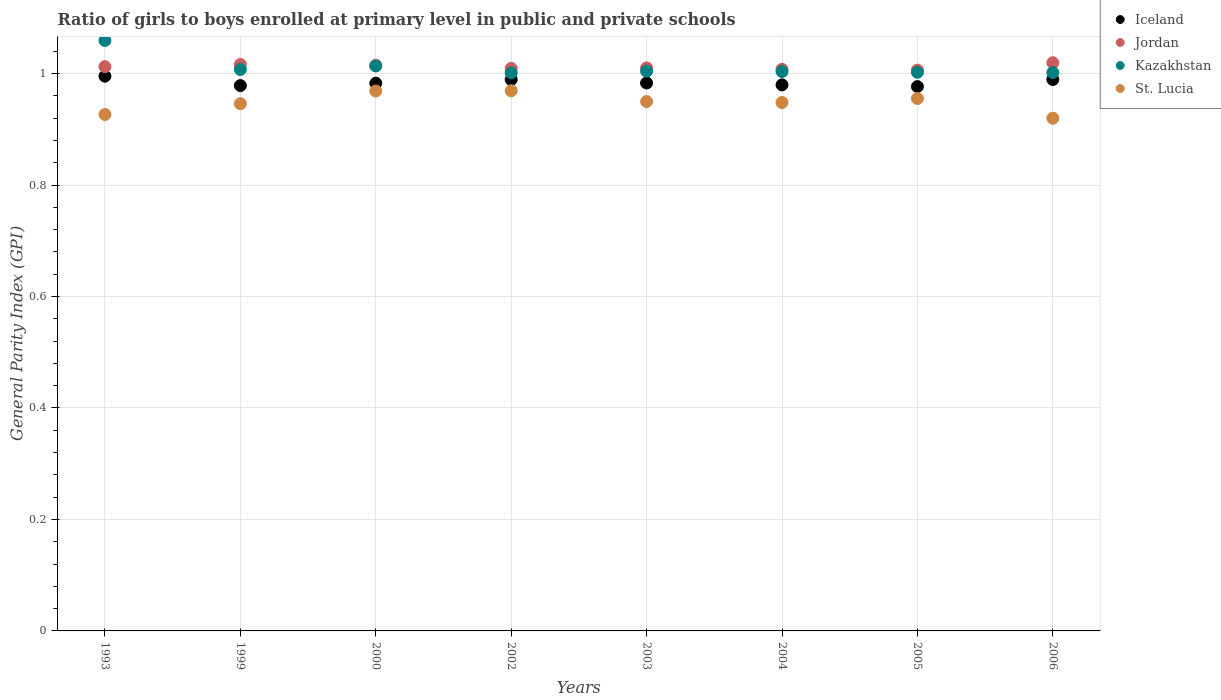Is the number of dotlines equal to the number of legend labels?
Provide a short and direct response. Yes. What is the general parity index in Kazakhstan in 2003?
Your response must be concise. 1. Across all years, what is the maximum general parity index in Iceland?
Your answer should be compact. 1. Across all years, what is the minimum general parity index in Iceland?
Provide a short and direct response. 0.98. What is the total general parity index in Jordan in the graph?
Offer a terse response. 8.1. What is the difference between the general parity index in Iceland in 2000 and that in 2003?
Your response must be concise. -0. What is the difference between the general parity index in St. Lucia in 1993 and the general parity index in Kazakhstan in 2000?
Your answer should be very brief. -0.09. What is the average general parity index in Jordan per year?
Make the answer very short. 1.01. In the year 2005, what is the difference between the general parity index in Kazakhstan and general parity index in St. Lucia?
Your answer should be very brief. 0.05. What is the ratio of the general parity index in Jordan in 1999 to that in 2005?
Provide a succinct answer. 1.01. What is the difference between the highest and the second highest general parity index in Jordan?
Your answer should be compact. 0. What is the difference between the highest and the lowest general parity index in Kazakhstan?
Provide a succinct answer. 0.06. In how many years, is the general parity index in Iceland greater than the average general parity index in Iceland taken over all years?
Offer a very short reply. 3. Is the sum of the general parity index in Iceland in 2002 and 2004 greater than the maximum general parity index in Jordan across all years?
Offer a very short reply. Yes. Is it the case that in every year, the sum of the general parity index in St. Lucia and general parity index in Jordan  is greater than the sum of general parity index in Iceland and general parity index in Kazakhstan?
Your response must be concise. Yes. Is it the case that in every year, the sum of the general parity index in St. Lucia and general parity index in Kazakhstan  is greater than the general parity index in Iceland?
Your answer should be compact. Yes. How many dotlines are there?
Make the answer very short. 4. How many years are there in the graph?
Keep it short and to the point. 8. What is the difference between two consecutive major ticks on the Y-axis?
Your answer should be very brief. 0.2. Are the values on the major ticks of Y-axis written in scientific E-notation?
Provide a succinct answer. No. Does the graph contain any zero values?
Offer a very short reply. No. Does the graph contain grids?
Offer a very short reply. Yes. Where does the legend appear in the graph?
Provide a succinct answer. Top right. How are the legend labels stacked?
Your response must be concise. Vertical. What is the title of the graph?
Your answer should be very brief. Ratio of girls to boys enrolled at primary level in public and private schools. Does "Turks and Caicos Islands" appear as one of the legend labels in the graph?
Offer a very short reply. No. What is the label or title of the Y-axis?
Keep it short and to the point. General Parity Index (GPI). What is the General Parity Index (GPI) of Jordan in 1993?
Provide a short and direct response. 1.01. What is the General Parity Index (GPI) of Kazakhstan in 1993?
Ensure brevity in your answer.  1.06. What is the General Parity Index (GPI) of St. Lucia in 1993?
Give a very brief answer. 0.93. What is the General Parity Index (GPI) in Iceland in 1999?
Give a very brief answer. 0.98. What is the General Parity Index (GPI) of Jordan in 1999?
Provide a short and direct response. 1.02. What is the General Parity Index (GPI) of Kazakhstan in 1999?
Keep it short and to the point. 1.01. What is the General Parity Index (GPI) in St. Lucia in 1999?
Offer a very short reply. 0.95. What is the General Parity Index (GPI) of Iceland in 2000?
Make the answer very short. 0.98. What is the General Parity Index (GPI) in Jordan in 2000?
Your answer should be compact. 1.01. What is the General Parity Index (GPI) of Kazakhstan in 2000?
Give a very brief answer. 1.01. What is the General Parity Index (GPI) of St. Lucia in 2000?
Give a very brief answer. 0.97. What is the General Parity Index (GPI) in Iceland in 2002?
Offer a very short reply. 0.99. What is the General Parity Index (GPI) of Jordan in 2002?
Give a very brief answer. 1.01. What is the General Parity Index (GPI) of Kazakhstan in 2002?
Offer a terse response. 1. What is the General Parity Index (GPI) in St. Lucia in 2002?
Make the answer very short. 0.97. What is the General Parity Index (GPI) of Iceland in 2003?
Your answer should be very brief. 0.98. What is the General Parity Index (GPI) in Jordan in 2003?
Your response must be concise. 1.01. What is the General Parity Index (GPI) in Kazakhstan in 2003?
Your answer should be compact. 1. What is the General Parity Index (GPI) of St. Lucia in 2003?
Provide a succinct answer. 0.95. What is the General Parity Index (GPI) in Iceland in 2004?
Your answer should be compact. 0.98. What is the General Parity Index (GPI) in Jordan in 2004?
Give a very brief answer. 1.01. What is the General Parity Index (GPI) of Kazakhstan in 2004?
Provide a short and direct response. 1. What is the General Parity Index (GPI) of St. Lucia in 2004?
Your response must be concise. 0.95. What is the General Parity Index (GPI) in Iceland in 2005?
Provide a short and direct response. 0.98. What is the General Parity Index (GPI) of Jordan in 2005?
Make the answer very short. 1.01. What is the General Parity Index (GPI) of Kazakhstan in 2005?
Make the answer very short. 1. What is the General Parity Index (GPI) in St. Lucia in 2005?
Provide a succinct answer. 0.96. What is the General Parity Index (GPI) of Iceland in 2006?
Your answer should be compact. 0.99. What is the General Parity Index (GPI) in Jordan in 2006?
Offer a very short reply. 1.02. What is the General Parity Index (GPI) of Kazakhstan in 2006?
Offer a terse response. 1. What is the General Parity Index (GPI) in St. Lucia in 2006?
Your response must be concise. 0.92. Across all years, what is the maximum General Parity Index (GPI) of Jordan?
Offer a very short reply. 1.02. Across all years, what is the maximum General Parity Index (GPI) of Kazakhstan?
Offer a very short reply. 1.06. Across all years, what is the maximum General Parity Index (GPI) of St. Lucia?
Ensure brevity in your answer.  0.97. Across all years, what is the minimum General Parity Index (GPI) in Iceland?
Provide a succinct answer. 0.98. Across all years, what is the minimum General Parity Index (GPI) in Jordan?
Keep it short and to the point. 1.01. Across all years, what is the minimum General Parity Index (GPI) in Kazakhstan?
Your answer should be compact. 1. Across all years, what is the minimum General Parity Index (GPI) in St. Lucia?
Provide a succinct answer. 0.92. What is the total General Parity Index (GPI) of Iceland in the graph?
Provide a short and direct response. 7.87. What is the total General Parity Index (GPI) of Jordan in the graph?
Make the answer very short. 8.1. What is the total General Parity Index (GPI) in Kazakhstan in the graph?
Give a very brief answer. 8.09. What is the total General Parity Index (GPI) in St. Lucia in the graph?
Ensure brevity in your answer.  7.58. What is the difference between the General Parity Index (GPI) of Iceland in 1993 and that in 1999?
Make the answer very short. 0.02. What is the difference between the General Parity Index (GPI) in Jordan in 1993 and that in 1999?
Keep it short and to the point. -0. What is the difference between the General Parity Index (GPI) of Kazakhstan in 1993 and that in 1999?
Give a very brief answer. 0.05. What is the difference between the General Parity Index (GPI) in St. Lucia in 1993 and that in 1999?
Make the answer very short. -0.02. What is the difference between the General Parity Index (GPI) in Iceland in 1993 and that in 2000?
Provide a succinct answer. 0.01. What is the difference between the General Parity Index (GPI) of Jordan in 1993 and that in 2000?
Make the answer very short. -0. What is the difference between the General Parity Index (GPI) in Kazakhstan in 1993 and that in 2000?
Provide a succinct answer. 0.05. What is the difference between the General Parity Index (GPI) of St. Lucia in 1993 and that in 2000?
Your answer should be very brief. -0.04. What is the difference between the General Parity Index (GPI) of Iceland in 1993 and that in 2002?
Offer a very short reply. 0.01. What is the difference between the General Parity Index (GPI) in Jordan in 1993 and that in 2002?
Offer a very short reply. 0. What is the difference between the General Parity Index (GPI) of Kazakhstan in 1993 and that in 2002?
Provide a succinct answer. 0.06. What is the difference between the General Parity Index (GPI) of St. Lucia in 1993 and that in 2002?
Keep it short and to the point. -0.04. What is the difference between the General Parity Index (GPI) of Iceland in 1993 and that in 2003?
Offer a terse response. 0.01. What is the difference between the General Parity Index (GPI) of Jordan in 1993 and that in 2003?
Provide a succinct answer. 0. What is the difference between the General Parity Index (GPI) of Kazakhstan in 1993 and that in 2003?
Your answer should be compact. 0.06. What is the difference between the General Parity Index (GPI) in St. Lucia in 1993 and that in 2003?
Your response must be concise. -0.02. What is the difference between the General Parity Index (GPI) in Iceland in 1993 and that in 2004?
Make the answer very short. 0.02. What is the difference between the General Parity Index (GPI) in Jordan in 1993 and that in 2004?
Make the answer very short. 0. What is the difference between the General Parity Index (GPI) in Kazakhstan in 1993 and that in 2004?
Provide a succinct answer. 0.06. What is the difference between the General Parity Index (GPI) in St. Lucia in 1993 and that in 2004?
Make the answer very short. -0.02. What is the difference between the General Parity Index (GPI) of Iceland in 1993 and that in 2005?
Your response must be concise. 0.02. What is the difference between the General Parity Index (GPI) in Jordan in 1993 and that in 2005?
Keep it short and to the point. 0.01. What is the difference between the General Parity Index (GPI) in Kazakhstan in 1993 and that in 2005?
Provide a short and direct response. 0.06. What is the difference between the General Parity Index (GPI) of St. Lucia in 1993 and that in 2005?
Your answer should be very brief. -0.03. What is the difference between the General Parity Index (GPI) in Iceland in 1993 and that in 2006?
Ensure brevity in your answer.  0.01. What is the difference between the General Parity Index (GPI) in Jordan in 1993 and that in 2006?
Keep it short and to the point. -0.01. What is the difference between the General Parity Index (GPI) of Kazakhstan in 1993 and that in 2006?
Your answer should be compact. 0.06. What is the difference between the General Parity Index (GPI) in St. Lucia in 1993 and that in 2006?
Your response must be concise. 0.01. What is the difference between the General Parity Index (GPI) in Iceland in 1999 and that in 2000?
Make the answer very short. -0. What is the difference between the General Parity Index (GPI) of Jordan in 1999 and that in 2000?
Offer a very short reply. 0. What is the difference between the General Parity Index (GPI) in Kazakhstan in 1999 and that in 2000?
Offer a terse response. -0.01. What is the difference between the General Parity Index (GPI) in St. Lucia in 1999 and that in 2000?
Ensure brevity in your answer.  -0.02. What is the difference between the General Parity Index (GPI) in Iceland in 1999 and that in 2002?
Your answer should be very brief. -0.01. What is the difference between the General Parity Index (GPI) in Jordan in 1999 and that in 2002?
Your response must be concise. 0.01. What is the difference between the General Parity Index (GPI) of Kazakhstan in 1999 and that in 2002?
Your answer should be very brief. 0.01. What is the difference between the General Parity Index (GPI) of St. Lucia in 1999 and that in 2002?
Keep it short and to the point. -0.02. What is the difference between the General Parity Index (GPI) in Iceland in 1999 and that in 2003?
Offer a terse response. -0. What is the difference between the General Parity Index (GPI) in Jordan in 1999 and that in 2003?
Provide a succinct answer. 0.01. What is the difference between the General Parity Index (GPI) of Kazakhstan in 1999 and that in 2003?
Provide a succinct answer. 0. What is the difference between the General Parity Index (GPI) in St. Lucia in 1999 and that in 2003?
Your response must be concise. -0. What is the difference between the General Parity Index (GPI) in Iceland in 1999 and that in 2004?
Your response must be concise. -0. What is the difference between the General Parity Index (GPI) in Jordan in 1999 and that in 2004?
Ensure brevity in your answer.  0.01. What is the difference between the General Parity Index (GPI) in Kazakhstan in 1999 and that in 2004?
Offer a very short reply. 0. What is the difference between the General Parity Index (GPI) of St. Lucia in 1999 and that in 2004?
Your answer should be compact. -0. What is the difference between the General Parity Index (GPI) in Iceland in 1999 and that in 2005?
Ensure brevity in your answer.  0. What is the difference between the General Parity Index (GPI) in Jordan in 1999 and that in 2005?
Ensure brevity in your answer.  0.01. What is the difference between the General Parity Index (GPI) in Kazakhstan in 1999 and that in 2005?
Provide a succinct answer. 0.01. What is the difference between the General Parity Index (GPI) of St. Lucia in 1999 and that in 2005?
Your answer should be compact. -0.01. What is the difference between the General Parity Index (GPI) of Iceland in 1999 and that in 2006?
Keep it short and to the point. -0.01. What is the difference between the General Parity Index (GPI) in Jordan in 1999 and that in 2006?
Provide a short and direct response. -0. What is the difference between the General Parity Index (GPI) in Kazakhstan in 1999 and that in 2006?
Ensure brevity in your answer.  0.01. What is the difference between the General Parity Index (GPI) of St. Lucia in 1999 and that in 2006?
Offer a terse response. 0.03. What is the difference between the General Parity Index (GPI) of Iceland in 2000 and that in 2002?
Your response must be concise. -0.01. What is the difference between the General Parity Index (GPI) of Jordan in 2000 and that in 2002?
Provide a succinct answer. 0.01. What is the difference between the General Parity Index (GPI) in Kazakhstan in 2000 and that in 2002?
Make the answer very short. 0.01. What is the difference between the General Parity Index (GPI) in St. Lucia in 2000 and that in 2002?
Make the answer very short. -0. What is the difference between the General Parity Index (GPI) of Iceland in 2000 and that in 2003?
Your response must be concise. -0. What is the difference between the General Parity Index (GPI) of Jordan in 2000 and that in 2003?
Keep it short and to the point. 0. What is the difference between the General Parity Index (GPI) of Kazakhstan in 2000 and that in 2003?
Make the answer very short. 0.01. What is the difference between the General Parity Index (GPI) in St. Lucia in 2000 and that in 2003?
Provide a succinct answer. 0.02. What is the difference between the General Parity Index (GPI) in Iceland in 2000 and that in 2004?
Give a very brief answer. 0. What is the difference between the General Parity Index (GPI) in Jordan in 2000 and that in 2004?
Make the answer very short. 0.01. What is the difference between the General Parity Index (GPI) of Kazakhstan in 2000 and that in 2004?
Ensure brevity in your answer.  0.01. What is the difference between the General Parity Index (GPI) of St. Lucia in 2000 and that in 2004?
Provide a short and direct response. 0.02. What is the difference between the General Parity Index (GPI) of Iceland in 2000 and that in 2005?
Give a very brief answer. 0.01. What is the difference between the General Parity Index (GPI) of Jordan in 2000 and that in 2005?
Your answer should be very brief. 0.01. What is the difference between the General Parity Index (GPI) in Kazakhstan in 2000 and that in 2005?
Your answer should be very brief. 0.01. What is the difference between the General Parity Index (GPI) of St. Lucia in 2000 and that in 2005?
Offer a very short reply. 0.01. What is the difference between the General Parity Index (GPI) in Iceland in 2000 and that in 2006?
Your response must be concise. -0.01. What is the difference between the General Parity Index (GPI) of Jordan in 2000 and that in 2006?
Your answer should be very brief. -0. What is the difference between the General Parity Index (GPI) in Kazakhstan in 2000 and that in 2006?
Provide a succinct answer. 0.01. What is the difference between the General Parity Index (GPI) in St. Lucia in 2000 and that in 2006?
Offer a very short reply. 0.05. What is the difference between the General Parity Index (GPI) in Iceland in 2002 and that in 2003?
Provide a succinct answer. 0.01. What is the difference between the General Parity Index (GPI) in Jordan in 2002 and that in 2003?
Provide a short and direct response. -0. What is the difference between the General Parity Index (GPI) in Kazakhstan in 2002 and that in 2003?
Make the answer very short. -0. What is the difference between the General Parity Index (GPI) of St. Lucia in 2002 and that in 2003?
Ensure brevity in your answer.  0.02. What is the difference between the General Parity Index (GPI) of Iceland in 2002 and that in 2004?
Offer a very short reply. 0.01. What is the difference between the General Parity Index (GPI) in Jordan in 2002 and that in 2004?
Keep it short and to the point. 0. What is the difference between the General Parity Index (GPI) of Kazakhstan in 2002 and that in 2004?
Your answer should be compact. -0. What is the difference between the General Parity Index (GPI) of St. Lucia in 2002 and that in 2004?
Provide a succinct answer. 0.02. What is the difference between the General Parity Index (GPI) of Iceland in 2002 and that in 2005?
Ensure brevity in your answer.  0.01. What is the difference between the General Parity Index (GPI) of Jordan in 2002 and that in 2005?
Offer a very short reply. 0. What is the difference between the General Parity Index (GPI) of Kazakhstan in 2002 and that in 2005?
Your answer should be very brief. -0. What is the difference between the General Parity Index (GPI) of St. Lucia in 2002 and that in 2005?
Keep it short and to the point. 0.01. What is the difference between the General Parity Index (GPI) of Iceland in 2002 and that in 2006?
Give a very brief answer. -0. What is the difference between the General Parity Index (GPI) in Jordan in 2002 and that in 2006?
Provide a short and direct response. -0.01. What is the difference between the General Parity Index (GPI) of Kazakhstan in 2002 and that in 2006?
Make the answer very short. -0. What is the difference between the General Parity Index (GPI) of St. Lucia in 2002 and that in 2006?
Keep it short and to the point. 0.05. What is the difference between the General Parity Index (GPI) of Iceland in 2003 and that in 2004?
Provide a short and direct response. 0. What is the difference between the General Parity Index (GPI) of Jordan in 2003 and that in 2004?
Provide a succinct answer. 0. What is the difference between the General Parity Index (GPI) of Kazakhstan in 2003 and that in 2004?
Your answer should be very brief. 0. What is the difference between the General Parity Index (GPI) of St. Lucia in 2003 and that in 2004?
Your answer should be very brief. 0. What is the difference between the General Parity Index (GPI) in Iceland in 2003 and that in 2005?
Offer a very short reply. 0.01. What is the difference between the General Parity Index (GPI) in Jordan in 2003 and that in 2005?
Ensure brevity in your answer.  0. What is the difference between the General Parity Index (GPI) of Kazakhstan in 2003 and that in 2005?
Keep it short and to the point. 0. What is the difference between the General Parity Index (GPI) of St. Lucia in 2003 and that in 2005?
Provide a succinct answer. -0.01. What is the difference between the General Parity Index (GPI) of Iceland in 2003 and that in 2006?
Keep it short and to the point. -0.01. What is the difference between the General Parity Index (GPI) in Jordan in 2003 and that in 2006?
Make the answer very short. -0.01. What is the difference between the General Parity Index (GPI) in Kazakhstan in 2003 and that in 2006?
Your response must be concise. 0. What is the difference between the General Parity Index (GPI) in St. Lucia in 2003 and that in 2006?
Give a very brief answer. 0.03. What is the difference between the General Parity Index (GPI) of Iceland in 2004 and that in 2005?
Ensure brevity in your answer.  0. What is the difference between the General Parity Index (GPI) in Jordan in 2004 and that in 2005?
Your response must be concise. 0. What is the difference between the General Parity Index (GPI) of Kazakhstan in 2004 and that in 2005?
Ensure brevity in your answer.  0. What is the difference between the General Parity Index (GPI) of St. Lucia in 2004 and that in 2005?
Give a very brief answer. -0.01. What is the difference between the General Parity Index (GPI) in Iceland in 2004 and that in 2006?
Your response must be concise. -0.01. What is the difference between the General Parity Index (GPI) in Jordan in 2004 and that in 2006?
Your answer should be very brief. -0.01. What is the difference between the General Parity Index (GPI) of Kazakhstan in 2004 and that in 2006?
Offer a terse response. 0. What is the difference between the General Parity Index (GPI) of St. Lucia in 2004 and that in 2006?
Offer a terse response. 0.03. What is the difference between the General Parity Index (GPI) of Iceland in 2005 and that in 2006?
Ensure brevity in your answer.  -0.01. What is the difference between the General Parity Index (GPI) of Jordan in 2005 and that in 2006?
Offer a terse response. -0.01. What is the difference between the General Parity Index (GPI) of Kazakhstan in 2005 and that in 2006?
Ensure brevity in your answer.  0. What is the difference between the General Parity Index (GPI) of St. Lucia in 2005 and that in 2006?
Give a very brief answer. 0.04. What is the difference between the General Parity Index (GPI) of Iceland in 1993 and the General Parity Index (GPI) of Jordan in 1999?
Offer a terse response. -0.02. What is the difference between the General Parity Index (GPI) in Iceland in 1993 and the General Parity Index (GPI) in Kazakhstan in 1999?
Offer a terse response. -0.01. What is the difference between the General Parity Index (GPI) of Iceland in 1993 and the General Parity Index (GPI) of St. Lucia in 1999?
Your response must be concise. 0.05. What is the difference between the General Parity Index (GPI) of Jordan in 1993 and the General Parity Index (GPI) of Kazakhstan in 1999?
Make the answer very short. 0.01. What is the difference between the General Parity Index (GPI) of Jordan in 1993 and the General Parity Index (GPI) of St. Lucia in 1999?
Give a very brief answer. 0.07. What is the difference between the General Parity Index (GPI) in Kazakhstan in 1993 and the General Parity Index (GPI) in St. Lucia in 1999?
Your answer should be compact. 0.11. What is the difference between the General Parity Index (GPI) in Iceland in 1993 and the General Parity Index (GPI) in Jordan in 2000?
Keep it short and to the point. -0.02. What is the difference between the General Parity Index (GPI) of Iceland in 1993 and the General Parity Index (GPI) of Kazakhstan in 2000?
Your answer should be compact. -0.02. What is the difference between the General Parity Index (GPI) of Iceland in 1993 and the General Parity Index (GPI) of St. Lucia in 2000?
Offer a terse response. 0.03. What is the difference between the General Parity Index (GPI) of Jordan in 1993 and the General Parity Index (GPI) of Kazakhstan in 2000?
Keep it short and to the point. -0. What is the difference between the General Parity Index (GPI) of Jordan in 1993 and the General Parity Index (GPI) of St. Lucia in 2000?
Your response must be concise. 0.04. What is the difference between the General Parity Index (GPI) in Kazakhstan in 1993 and the General Parity Index (GPI) in St. Lucia in 2000?
Your answer should be very brief. 0.09. What is the difference between the General Parity Index (GPI) in Iceland in 1993 and the General Parity Index (GPI) in Jordan in 2002?
Provide a short and direct response. -0.01. What is the difference between the General Parity Index (GPI) in Iceland in 1993 and the General Parity Index (GPI) in Kazakhstan in 2002?
Offer a terse response. -0.01. What is the difference between the General Parity Index (GPI) in Iceland in 1993 and the General Parity Index (GPI) in St. Lucia in 2002?
Keep it short and to the point. 0.03. What is the difference between the General Parity Index (GPI) of Jordan in 1993 and the General Parity Index (GPI) of Kazakhstan in 2002?
Provide a short and direct response. 0.01. What is the difference between the General Parity Index (GPI) in Jordan in 1993 and the General Parity Index (GPI) in St. Lucia in 2002?
Give a very brief answer. 0.04. What is the difference between the General Parity Index (GPI) of Kazakhstan in 1993 and the General Parity Index (GPI) of St. Lucia in 2002?
Keep it short and to the point. 0.09. What is the difference between the General Parity Index (GPI) in Iceland in 1993 and the General Parity Index (GPI) in Jordan in 2003?
Give a very brief answer. -0.01. What is the difference between the General Parity Index (GPI) of Iceland in 1993 and the General Parity Index (GPI) of Kazakhstan in 2003?
Keep it short and to the point. -0.01. What is the difference between the General Parity Index (GPI) of Iceland in 1993 and the General Parity Index (GPI) of St. Lucia in 2003?
Offer a terse response. 0.05. What is the difference between the General Parity Index (GPI) in Jordan in 1993 and the General Parity Index (GPI) in Kazakhstan in 2003?
Your answer should be compact. 0.01. What is the difference between the General Parity Index (GPI) in Jordan in 1993 and the General Parity Index (GPI) in St. Lucia in 2003?
Keep it short and to the point. 0.06. What is the difference between the General Parity Index (GPI) in Kazakhstan in 1993 and the General Parity Index (GPI) in St. Lucia in 2003?
Provide a succinct answer. 0.11. What is the difference between the General Parity Index (GPI) of Iceland in 1993 and the General Parity Index (GPI) of Jordan in 2004?
Keep it short and to the point. -0.01. What is the difference between the General Parity Index (GPI) of Iceland in 1993 and the General Parity Index (GPI) of Kazakhstan in 2004?
Give a very brief answer. -0.01. What is the difference between the General Parity Index (GPI) in Iceland in 1993 and the General Parity Index (GPI) in St. Lucia in 2004?
Your answer should be compact. 0.05. What is the difference between the General Parity Index (GPI) in Jordan in 1993 and the General Parity Index (GPI) in Kazakhstan in 2004?
Provide a short and direct response. 0.01. What is the difference between the General Parity Index (GPI) of Jordan in 1993 and the General Parity Index (GPI) of St. Lucia in 2004?
Make the answer very short. 0.06. What is the difference between the General Parity Index (GPI) in Kazakhstan in 1993 and the General Parity Index (GPI) in St. Lucia in 2004?
Your response must be concise. 0.11. What is the difference between the General Parity Index (GPI) of Iceland in 1993 and the General Parity Index (GPI) of Jordan in 2005?
Provide a succinct answer. -0.01. What is the difference between the General Parity Index (GPI) in Iceland in 1993 and the General Parity Index (GPI) in Kazakhstan in 2005?
Your response must be concise. -0.01. What is the difference between the General Parity Index (GPI) of Jordan in 1993 and the General Parity Index (GPI) of Kazakhstan in 2005?
Offer a terse response. 0.01. What is the difference between the General Parity Index (GPI) of Jordan in 1993 and the General Parity Index (GPI) of St. Lucia in 2005?
Offer a terse response. 0.06. What is the difference between the General Parity Index (GPI) of Kazakhstan in 1993 and the General Parity Index (GPI) of St. Lucia in 2005?
Your response must be concise. 0.1. What is the difference between the General Parity Index (GPI) in Iceland in 1993 and the General Parity Index (GPI) in Jordan in 2006?
Your answer should be compact. -0.02. What is the difference between the General Parity Index (GPI) in Iceland in 1993 and the General Parity Index (GPI) in Kazakhstan in 2006?
Your answer should be very brief. -0.01. What is the difference between the General Parity Index (GPI) in Iceland in 1993 and the General Parity Index (GPI) in St. Lucia in 2006?
Ensure brevity in your answer.  0.08. What is the difference between the General Parity Index (GPI) of Jordan in 1993 and the General Parity Index (GPI) of Kazakhstan in 2006?
Provide a succinct answer. 0.01. What is the difference between the General Parity Index (GPI) in Jordan in 1993 and the General Parity Index (GPI) in St. Lucia in 2006?
Provide a short and direct response. 0.09. What is the difference between the General Parity Index (GPI) of Kazakhstan in 1993 and the General Parity Index (GPI) of St. Lucia in 2006?
Provide a short and direct response. 0.14. What is the difference between the General Parity Index (GPI) of Iceland in 1999 and the General Parity Index (GPI) of Jordan in 2000?
Your response must be concise. -0.04. What is the difference between the General Parity Index (GPI) in Iceland in 1999 and the General Parity Index (GPI) in Kazakhstan in 2000?
Provide a short and direct response. -0.04. What is the difference between the General Parity Index (GPI) in Iceland in 1999 and the General Parity Index (GPI) in St. Lucia in 2000?
Ensure brevity in your answer.  0.01. What is the difference between the General Parity Index (GPI) in Jordan in 1999 and the General Parity Index (GPI) in Kazakhstan in 2000?
Keep it short and to the point. 0. What is the difference between the General Parity Index (GPI) in Jordan in 1999 and the General Parity Index (GPI) in St. Lucia in 2000?
Your answer should be very brief. 0.05. What is the difference between the General Parity Index (GPI) of Kazakhstan in 1999 and the General Parity Index (GPI) of St. Lucia in 2000?
Your answer should be very brief. 0.04. What is the difference between the General Parity Index (GPI) in Iceland in 1999 and the General Parity Index (GPI) in Jordan in 2002?
Ensure brevity in your answer.  -0.03. What is the difference between the General Parity Index (GPI) of Iceland in 1999 and the General Parity Index (GPI) of Kazakhstan in 2002?
Provide a succinct answer. -0.02. What is the difference between the General Parity Index (GPI) of Iceland in 1999 and the General Parity Index (GPI) of St. Lucia in 2002?
Provide a short and direct response. 0.01. What is the difference between the General Parity Index (GPI) of Jordan in 1999 and the General Parity Index (GPI) of Kazakhstan in 2002?
Keep it short and to the point. 0.02. What is the difference between the General Parity Index (GPI) of Jordan in 1999 and the General Parity Index (GPI) of St. Lucia in 2002?
Provide a short and direct response. 0.05. What is the difference between the General Parity Index (GPI) in Kazakhstan in 1999 and the General Parity Index (GPI) in St. Lucia in 2002?
Ensure brevity in your answer.  0.04. What is the difference between the General Parity Index (GPI) in Iceland in 1999 and the General Parity Index (GPI) in Jordan in 2003?
Offer a terse response. -0.03. What is the difference between the General Parity Index (GPI) of Iceland in 1999 and the General Parity Index (GPI) of Kazakhstan in 2003?
Ensure brevity in your answer.  -0.03. What is the difference between the General Parity Index (GPI) in Iceland in 1999 and the General Parity Index (GPI) in St. Lucia in 2003?
Your answer should be very brief. 0.03. What is the difference between the General Parity Index (GPI) of Jordan in 1999 and the General Parity Index (GPI) of Kazakhstan in 2003?
Keep it short and to the point. 0.01. What is the difference between the General Parity Index (GPI) in Jordan in 1999 and the General Parity Index (GPI) in St. Lucia in 2003?
Ensure brevity in your answer.  0.07. What is the difference between the General Parity Index (GPI) of Kazakhstan in 1999 and the General Parity Index (GPI) of St. Lucia in 2003?
Keep it short and to the point. 0.06. What is the difference between the General Parity Index (GPI) of Iceland in 1999 and the General Parity Index (GPI) of Jordan in 2004?
Offer a terse response. -0.03. What is the difference between the General Parity Index (GPI) of Iceland in 1999 and the General Parity Index (GPI) of Kazakhstan in 2004?
Keep it short and to the point. -0.03. What is the difference between the General Parity Index (GPI) in Iceland in 1999 and the General Parity Index (GPI) in St. Lucia in 2004?
Ensure brevity in your answer.  0.03. What is the difference between the General Parity Index (GPI) in Jordan in 1999 and the General Parity Index (GPI) in Kazakhstan in 2004?
Provide a short and direct response. 0.01. What is the difference between the General Parity Index (GPI) in Jordan in 1999 and the General Parity Index (GPI) in St. Lucia in 2004?
Ensure brevity in your answer.  0.07. What is the difference between the General Parity Index (GPI) in Kazakhstan in 1999 and the General Parity Index (GPI) in St. Lucia in 2004?
Your response must be concise. 0.06. What is the difference between the General Parity Index (GPI) of Iceland in 1999 and the General Parity Index (GPI) of Jordan in 2005?
Offer a very short reply. -0.03. What is the difference between the General Parity Index (GPI) of Iceland in 1999 and the General Parity Index (GPI) of Kazakhstan in 2005?
Your answer should be compact. -0.02. What is the difference between the General Parity Index (GPI) in Iceland in 1999 and the General Parity Index (GPI) in St. Lucia in 2005?
Your response must be concise. 0.02. What is the difference between the General Parity Index (GPI) of Jordan in 1999 and the General Parity Index (GPI) of Kazakhstan in 2005?
Provide a succinct answer. 0.01. What is the difference between the General Parity Index (GPI) in Jordan in 1999 and the General Parity Index (GPI) in St. Lucia in 2005?
Keep it short and to the point. 0.06. What is the difference between the General Parity Index (GPI) in Kazakhstan in 1999 and the General Parity Index (GPI) in St. Lucia in 2005?
Your response must be concise. 0.05. What is the difference between the General Parity Index (GPI) of Iceland in 1999 and the General Parity Index (GPI) of Jordan in 2006?
Give a very brief answer. -0.04. What is the difference between the General Parity Index (GPI) in Iceland in 1999 and the General Parity Index (GPI) in Kazakhstan in 2006?
Your answer should be very brief. -0.02. What is the difference between the General Parity Index (GPI) in Iceland in 1999 and the General Parity Index (GPI) in St. Lucia in 2006?
Ensure brevity in your answer.  0.06. What is the difference between the General Parity Index (GPI) in Jordan in 1999 and the General Parity Index (GPI) in Kazakhstan in 2006?
Your response must be concise. 0.01. What is the difference between the General Parity Index (GPI) of Jordan in 1999 and the General Parity Index (GPI) of St. Lucia in 2006?
Make the answer very short. 0.1. What is the difference between the General Parity Index (GPI) of Kazakhstan in 1999 and the General Parity Index (GPI) of St. Lucia in 2006?
Provide a short and direct response. 0.09. What is the difference between the General Parity Index (GPI) in Iceland in 2000 and the General Parity Index (GPI) in Jordan in 2002?
Give a very brief answer. -0.03. What is the difference between the General Parity Index (GPI) of Iceland in 2000 and the General Parity Index (GPI) of Kazakhstan in 2002?
Give a very brief answer. -0.02. What is the difference between the General Parity Index (GPI) of Iceland in 2000 and the General Parity Index (GPI) of St. Lucia in 2002?
Keep it short and to the point. 0.01. What is the difference between the General Parity Index (GPI) of Jordan in 2000 and the General Parity Index (GPI) of Kazakhstan in 2002?
Make the answer very short. 0.01. What is the difference between the General Parity Index (GPI) in Jordan in 2000 and the General Parity Index (GPI) in St. Lucia in 2002?
Your response must be concise. 0.05. What is the difference between the General Parity Index (GPI) in Kazakhstan in 2000 and the General Parity Index (GPI) in St. Lucia in 2002?
Provide a succinct answer. 0.04. What is the difference between the General Parity Index (GPI) of Iceland in 2000 and the General Parity Index (GPI) of Jordan in 2003?
Give a very brief answer. -0.03. What is the difference between the General Parity Index (GPI) in Iceland in 2000 and the General Parity Index (GPI) in Kazakhstan in 2003?
Make the answer very short. -0.02. What is the difference between the General Parity Index (GPI) of Iceland in 2000 and the General Parity Index (GPI) of St. Lucia in 2003?
Keep it short and to the point. 0.03. What is the difference between the General Parity Index (GPI) in Jordan in 2000 and the General Parity Index (GPI) in Kazakhstan in 2003?
Ensure brevity in your answer.  0.01. What is the difference between the General Parity Index (GPI) in Jordan in 2000 and the General Parity Index (GPI) in St. Lucia in 2003?
Offer a terse response. 0.07. What is the difference between the General Parity Index (GPI) of Kazakhstan in 2000 and the General Parity Index (GPI) of St. Lucia in 2003?
Your answer should be very brief. 0.06. What is the difference between the General Parity Index (GPI) in Iceland in 2000 and the General Parity Index (GPI) in Jordan in 2004?
Provide a succinct answer. -0.02. What is the difference between the General Parity Index (GPI) of Iceland in 2000 and the General Parity Index (GPI) of Kazakhstan in 2004?
Your answer should be very brief. -0.02. What is the difference between the General Parity Index (GPI) in Iceland in 2000 and the General Parity Index (GPI) in St. Lucia in 2004?
Your response must be concise. 0.03. What is the difference between the General Parity Index (GPI) of Jordan in 2000 and the General Parity Index (GPI) of Kazakhstan in 2004?
Offer a terse response. 0.01. What is the difference between the General Parity Index (GPI) in Jordan in 2000 and the General Parity Index (GPI) in St. Lucia in 2004?
Give a very brief answer. 0.07. What is the difference between the General Parity Index (GPI) of Kazakhstan in 2000 and the General Parity Index (GPI) of St. Lucia in 2004?
Provide a succinct answer. 0.07. What is the difference between the General Parity Index (GPI) of Iceland in 2000 and the General Parity Index (GPI) of Jordan in 2005?
Your answer should be compact. -0.02. What is the difference between the General Parity Index (GPI) in Iceland in 2000 and the General Parity Index (GPI) in Kazakhstan in 2005?
Your answer should be very brief. -0.02. What is the difference between the General Parity Index (GPI) in Iceland in 2000 and the General Parity Index (GPI) in St. Lucia in 2005?
Your answer should be very brief. 0.03. What is the difference between the General Parity Index (GPI) in Jordan in 2000 and the General Parity Index (GPI) in Kazakhstan in 2005?
Your answer should be compact. 0.01. What is the difference between the General Parity Index (GPI) in Jordan in 2000 and the General Parity Index (GPI) in St. Lucia in 2005?
Your answer should be very brief. 0.06. What is the difference between the General Parity Index (GPI) in Kazakhstan in 2000 and the General Parity Index (GPI) in St. Lucia in 2005?
Your response must be concise. 0.06. What is the difference between the General Parity Index (GPI) in Iceland in 2000 and the General Parity Index (GPI) in Jordan in 2006?
Your answer should be compact. -0.04. What is the difference between the General Parity Index (GPI) of Iceland in 2000 and the General Parity Index (GPI) of Kazakhstan in 2006?
Ensure brevity in your answer.  -0.02. What is the difference between the General Parity Index (GPI) in Iceland in 2000 and the General Parity Index (GPI) in St. Lucia in 2006?
Keep it short and to the point. 0.06. What is the difference between the General Parity Index (GPI) in Jordan in 2000 and the General Parity Index (GPI) in Kazakhstan in 2006?
Provide a short and direct response. 0.01. What is the difference between the General Parity Index (GPI) in Jordan in 2000 and the General Parity Index (GPI) in St. Lucia in 2006?
Your answer should be very brief. 0.1. What is the difference between the General Parity Index (GPI) in Kazakhstan in 2000 and the General Parity Index (GPI) in St. Lucia in 2006?
Ensure brevity in your answer.  0.09. What is the difference between the General Parity Index (GPI) of Iceland in 2002 and the General Parity Index (GPI) of Jordan in 2003?
Make the answer very short. -0.02. What is the difference between the General Parity Index (GPI) of Iceland in 2002 and the General Parity Index (GPI) of Kazakhstan in 2003?
Your answer should be compact. -0.02. What is the difference between the General Parity Index (GPI) in Iceland in 2002 and the General Parity Index (GPI) in St. Lucia in 2003?
Keep it short and to the point. 0.04. What is the difference between the General Parity Index (GPI) in Jordan in 2002 and the General Parity Index (GPI) in Kazakhstan in 2003?
Make the answer very short. 0. What is the difference between the General Parity Index (GPI) in Jordan in 2002 and the General Parity Index (GPI) in St. Lucia in 2003?
Ensure brevity in your answer.  0.06. What is the difference between the General Parity Index (GPI) in Kazakhstan in 2002 and the General Parity Index (GPI) in St. Lucia in 2003?
Your response must be concise. 0.05. What is the difference between the General Parity Index (GPI) in Iceland in 2002 and the General Parity Index (GPI) in Jordan in 2004?
Your response must be concise. -0.02. What is the difference between the General Parity Index (GPI) of Iceland in 2002 and the General Parity Index (GPI) of Kazakhstan in 2004?
Provide a short and direct response. -0.01. What is the difference between the General Parity Index (GPI) in Iceland in 2002 and the General Parity Index (GPI) in St. Lucia in 2004?
Ensure brevity in your answer.  0.04. What is the difference between the General Parity Index (GPI) in Jordan in 2002 and the General Parity Index (GPI) in Kazakhstan in 2004?
Make the answer very short. 0.01. What is the difference between the General Parity Index (GPI) in Jordan in 2002 and the General Parity Index (GPI) in St. Lucia in 2004?
Offer a very short reply. 0.06. What is the difference between the General Parity Index (GPI) in Kazakhstan in 2002 and the General Parity Index (GPI) in St. Lucia in 2004?
Ensure brevity in your answer.  0.05. What is the difference between the General Parity Index (GPI) in Iceland in 2002 and the General Parity Index (GPI) in Jordan in 2005?
Your response must be concise. -0.02. What is the difference between the General Parity Index (GPI) of Iceland in 2002 and the General Parity Index (GPI) of Kazakhstan in 2005?
Give a very brief answer. -0.01. What is the difference between the General Parity Index (GPI) in Iceland in 2002 and the General Parity Index (GPI) in St. Lucia in 2005?
Your answer should be very brief. 0.03. What is the difference between the General Parity Index (GPI) of Jordan in 2002 and the General Parity Index (GPI) of Kazakhstan in 2005?
Offer a very short reply. 0.01. What is the difference between the General Parity Index (GPI) of Jordan in 2002 and the General Parity Index (GPI) of St. Lucia in 2005?
Keep it short and to the point. 0.05. What is the difference between the General Parity Index (GPI) in Kazakhstan in 2002 and the General Parity Index (GPI) in St. Lucia in 2005?
Your answer should be very brief. 0.05. What is the difference between the General Parity Index (GPI) of Iceland in 2002 and the General Parity Index (GPI) of Jordan in 2006?
Keep it short and to the point. -0.03. What is the difference between the General Parity Index (GPI) in Iceland in 2002 and the General Parity Index (GPI) in Kazakhstan in 2006?
Give a very brief answer. -0.01. What is the difference between the General Parity Index (GPI) of Iceland in 2002 and the General Parity Index (GPI) of St. Lucia in 2006?
Give a very brief answer. 0.07. What is the difference between the General Parity Index (GPI) of Jordan in 2002 and the General Parity Index (GPI) of Kazakhstan in 2006?
Offer a terse response. 0.01. What is the difference between the General Parity Index (GPI) in Jordan in 2002 and the General Parity Index (GPI) in St. Lucia in 2006?
Provide a succinct answer. 0.09. What is the difference between the General Parity Index (GPI) in Kazakhstan in 2002 and the General Parity Index (GPI) in St. Lucia in 2006?
Give a very brief answer. 0.08. What is the difference between the General Parity Index (GPI) in Iceland in 2003 and the General Parity Index (GPI) in Jordan in 2004?
Your answer should be compact. -0.02. What is the difference between the General Parity Index (GPI) of Iceland in 2003 and the General Parity Index (GPI) of Kazakhstan in 2004?
Your answer should be very brief. -0.02. What is the difference between the General Parity Index (GPI) in Iceland in 2003 and the General Parity Index (GPI) in St. Lucia in 2004?
Make the answer very short. 0.04. What is the difference between the General Parity Index (GPI) of Jordan in 2003 and the General Parity Index (GPI) of Kazakhstan in 2004?
Offer a very short reply. 0.01. What is the difference between the General Parity Index (GPI) of Jordan in 2003 and the General Parity Index (GPI) of St. Lucia in 2004?
Offer a very short reply. 0.06. What is the difference between the General Parity Index (GPI) in Kazakhstan in 2003 and the General Parity Index (GPI) in St. Lucia in 2004?
Your answer should be very brief. 0.06. What is the difference between the General Parity Index (GPI) of Iceland in 2003 and the General Parity Index (GPI) of Jordan in 2005?
Your answer should be compact. -0.02. What is the difference between the General Parity Index (GPI) in Iceland in 2003 and the General Parity Index (GPI) in Kazakhstan in 2005?
Provide a short and direct response. -0.02. What is the difference between the General Parity Index (GPI) in Iceland in 2003 and the General Parity Index (GPI) in St. Lucia in 2005?
Your response must be concise. 0.03. What is the difference between the General Parity Index (GPI) of Jordan in 2003 and the General Parity Index (GPI) of Kazakhstan in 2005?
Your response must be concise. 0.01. What is the difference between the General Parity Index (GPI) of Jordan in 2003 and the General Parity Index (GPI) of St. Lucia in 2005?
Make the answer very short. 0.05. What is the difference between the General Parity Index (GPI) of Kazakhstan in 2003 and the General Parity Index (GPI) of St. Lucia in 2005?
Offer a terse response. 0.05. What is the difference between the General Parity Index (GPI) in Iceland in 2003 and the General Parity Index (GPI) in Jordan in 2006?
Provide a short and direct response. -0.04. What is the difference between the General Parity Index (GPI) of Iceland in 2003 and the General Parity Index (GPI) of Kazakhstan in 2006?
Offer a very short reply. -0.02. What is the difference between the General Parity Index (GPI) in Iceland in 2003 and the General Parity Index (GPI) in St. Lucia in 2006?
Make the answer very short. 0.06. What is the difference between the General Parity Index (GPI) of Jordan in 2003 and the General Parity Index (GPI) of Kazakhstan in 2006?
Offer a terse response. 0.01. What is the difference between the General Parity Index (GPI) of Jordan in 2003 and the General Parity Index (GPI) of St. Lucia in 2006?
Offer a very short reply. 0.09. What is the difference between the General Parity Index (GPI) of Kazakhstan in 2003 and the General Parity Index (GPI) of St. Lucia in 2006?
Offer a terse response. 0.08. What is the difference between the General Parity Index (GPI) of Iceland in 2004 and the General Parity Index (GPI) of Jordan in 2005?
Make the answer very short. -0.03. What is the difference between the General Parity Index (GPI) in Iceland in 2004 and the General Parity Index (GPI) in Kazakhstan in 2005?
Your answer should be very brief. -0.02. What is the difference between the General Parity Index (GPI) in Iceland in 2004 and the General Parity Index (GPI) in St. Lucia in 2005?
Give a very brief answer. 0.02. What is the difference between the General Parity Index (GPI) in Jordan in 2004 and the General Parity Index (GPI) in Kazakhstan in 2005?
Offer a very short reply. 0.01. What is the difference between the General Parity Index (GPI) in Jordan in 2004 and the General Parity Index (GPI) in St. Lucia in 2005?
Make the answer very short. 0.05. What is the difference between the General Parity Index (GPI) of Kazakhstan in 2004 and the General Parity Index (GPI) of St. Lucia in 2005?
Offer a very short reply. 0.05. What is the difference between the General Parity Index (GPI) in Iceland in 2004 and the General Parity Index (GPI) in Jordan in 2006?
Make the answer very short. -0.04. What is the difference between the General Parity Index (GPI) in Iceland in 2004 and the General Parity Index (GPI) in Kazakhstan in 2006?
Make the answer very short. -0.02. What is the difference between the General Parity Index (GPI) of Iceland in 2004 and the General Parity Index (GPI) of St. Lucia in 2006?
Your answer should be compact. 0.06. What is the difference between the General Parity Index (GPI) of Jordan in 2004 and the General Parity Index (GPI) of Kazakhstan in 2006?
Offer a very short reply. 0.01. What is the difference between the General Parity Index (GPI) in Jordan in 2004 and the General Parity Index (GPI) in St. Lucia in 2006?
Your answer should be very brief. 0.09. What is the difference between the General Parity Index (GPI) in Kazakhstan in 2004 and the General Parity Index (GPI) in St. Lucia in 2006?
Offer a terse response. 0.08. What is the difference between the General Parity Index (GPI) in Iceland in 2005 and the General Parity Index (GPI) in Jordan in 2006?
Provide a succinct answer. -0.04. What is the difference between the General Parity Index (GPI) in Iceland in 2005 and the General Parity Index (GPI) in Kazakhstan in 2006?
Provide a short and direct response. -0.03. What is the difference between the General Parity Index (GPI) of Iceland in 2005 and the General Parity Index (GPI) of St. Lucia in 2006?
Make the answer very short. 0.06. What is the difference between the General Parity Index (GPI) of Jordan in 2005 and the General Parity Index (GPI) of Kazakhstan in 2006?
Make the answer very short. 0. What is the difference between the General Parity Index (GPI) of Jordan in 2005 and the General Parity Index (GPI) of St. Lucia in 2006?
Give a very brief answer. 0.09. What is the difference between the General Parity Index (GPI) of Kazakhstan in 2005 and the General Parity Index (GPI) of St. Lucia in 2006?
Make the answer very short. 0.08. What is the average General Parity Index (GPI) of Iceland per year?
Keep it short and to the point. 0.98. What is the average General Parity Index (GPI) of Jordan per year?
Your answer should be compact. 1.01. What is the average General Parity Index (GPI) in Kazakhstan per year?
Your answer should be very brief. 1.01. What is the average General Parity Index (GPI) in St. Lucia per year?
Your answer should be compact. 0.95. In the year 1993, what is the difference between the General Parity Index (GPI) of Iceland and General Parity Index (GPI) of Jordan?
Make the answer very short. -0.02. In the year 1993, what is the difference between the General Parity Index (GPI) in Iceland and General Parity Index (GPI) in Kazakhstan?
Ensure brevity in your answer.  -0.06. In the year 1993, what is the difference between the General Parity Index (GPI) in Iceland and General Parity Index (GPI) in St. Lucia?
Offer a terse response. 0.07. In the year 1993, what is the difference between the General Parity Index (GPI) of Jordan and General Parity Index (GPI) of Kazakhstan?
Keep it short and to the point. -0.05. In the year 1993, what is the difference between the General Parity Index (GPI) of Jordan and General Parity Index (GPI) of St. Lucia?
Make the answer very short. 0.09. In the year 1993, what is the difference between the General Parity Index (GPI) of Kazakhstan and General Parity Index (GPI) of St. Lucia?
Provide a succinct answer. 0.13. In the year 1999, what is the difference between the General Parity Index (GPI) of Iceland and General Parity Index (GPI) of Jordan?
Ensure brevity in your answer.  -0.04. In the year 1999, what is the difference between the General Parity Index (GPI) of Iceland and General Parity Index (GPI) of Kazakhstan?
Your answer should be compact. -0.03. In the year 1999, what is the difference between the General Parity Index (GPI) in Iceland and General Parity Index (GPI) in St. Lucia?
Ensure brevity in your answer.  0.03. In the year 1999, what is the difference between the General Parity Index (GPI) of Jordan and General Parity Index (GPI) of Kazakhstan?
Your answer should be very brief. 0.01. In the year 1999, what is the difference between the General Parity Index (GPI) of Jordan and General Parity Index (GPI) of St. Lucia?
Offer a terse response. 0.07. In the year 1999, what is the difference between the General Parity Index (GPI) of Kazakhstan and General Parity Index (GPI) of St. Lucia?
Offer a terse response. 0.06. In the year 2000, what is the difference between the General Parity Index (GPI) of Iceland and General Parity Index (GPI) of Jordan?
Give a very brief answer. -0.03. In the year 2000, what is the difference between the General Parity Index (GPI) of Iceland and General Parity Index (GPI) of Kazakhstan?
Offer a terse response. -0.03. In the year 2000, what is the difference between the General Parity Index (GPI) in Iceland and General Parity Index (GPI) in St. Lucia?
Your answer should be very brief. 0.01. In the year 2000, what is the difference between the General Parity Index (GPI) of Jordan and General Parity Index (GPI) of Kazakhstan?
Provide a short and direct response. 0. In the year 2000, what is the difference between the General Parity Index (GPI) of Jordan and General Parity Index (GPI) of St. Lucia?
Offer a terse response. 0.05. In the year 2000, what is the difference between the General Parity Index (GPI) of Kazakhstan and General Parity Index (GPI) of St. Lucia?
Provide a short and direct response. 0.04. In the year 2002, what is the difference between the General Parity Index (GPI) of Iceland and General Parity Index (GPI) of Jordan?
Your answer should be very brief. -0.02. In the year 2002, what is the difference between the General Parity Index (GPI) in Iceland and General Parity Index (GPI) in Kazakhstan?
Your answer should be compact. -0.01. In the year 2002, what is the difference between the General Parity Index (GPI) in Iceland and General Parity Index (GPI) in St. Lucia?
Provide a short and direct response. 0.02. In the year 2002, what is the difference between the General Parity Index (GPI) in Jordan and General Parity Index (GPI) in Kazakhstan?
Give a very brief answer. 0.01. In the year 2002, what is the difference between the General Parity Index (GPI) in Jordan and General Parity Index (GPI) in St. Lucia?
Provide a succinct answer. 0.04. In the year 2002, what is the difference between the General Parity Index (GPI) of Kazakhstan and General Parity Index (GPI) of St. Lucia?
Your response must be concise. 0.03. In the year 2003, what is the difference between the General Parity Index (GPI) of Iceland and General Parity Index (GPI) of Jordan?
Keep it short and to the point. -0.03. In the year 2003, what is the difference between the General Parity Index (GPI) in Iceland and General Parity Index (GPI) in Kazakhstan?
Your answer should be very brief. -0.02. In the year 2003, what is the difference between the General Parity Index (GPI) in Jordan and General Parity Index (GPI) in Kazakhstan?
Your response must be concise. 0.01. In the year 2003, what is the difference between the General Parity Index (GPI) in Jordan and General Parity Index (GPI) in St. Lucia?
Your answer should be compact. 0.06. In the year 2003, what is the difference between the General Parity Index (GPI) in Kazakhstan and General Parity Index (GPI) in St. Lucia?
Ensure brevity in your answer.  0.05. In the year 2004, what is the difference between the General Parity Index (GPI) in Iceland and General Parity Index (GPI) in Jordan?
Your answer should be very brief. -0.03. In the year 2004, what is the difference between the General Parity Index (GPI) in Iceland and General Parity Index (GPI) in Kazakhstan?
Keep it short and to the point. -0.02. In the year 2004, what is the difference between the General Parity Index (GPI) in Iceland and General Parity Index (GPI) in St. Lucia?
Your response must be concise. 0.03. In the year 2004, what is the difference between the General Parity Index (GPI) in Jordan and General Parity Index (GPI) in Kazakhstan?
Offer a very short reply. 0. In the year 2004, what is the difference between the General Parity Index (GPI) of Jordan and General Parity Index (GPI) of St. Lucia?
Your response must be concise. 0.06. In the year 2004, what is the difference between the General Parity Index (GPI) of Kazakhstan and General Parity Index (GPI) of St. Lucia?
Provide a succinct answer. 0.06. In the year 2005, what is the difference between the General Parity Index (GPI) of Iceland and General Parity Index (GPI) of Jordan?
Make the answer very short. -0.03. In the year 2005, what is the difference between the General Parity Index (GPI) in Iceland and General Parity Index (GPI) in Kazakhstan?
Keep it short and to the point. -0.03. In the year 2005, what is the difference between the General Parity Index (GPI) of Iceland and General Parity Index (GPI) of St. Lucia?
Your answer should be compact. 0.02. In the year 2005, what is the difference between the General Parity Index (GPI) in Jordan and General Parity Index (GPI) in Kazakhstan?
Provide a succinct answer. 0. In the year 2005, what is the difference between the General Parity Index (GPI) in Jordan and General Parity Index (GPI) in St. Lucia?
Provide a succinct answer. 0.05. In the year 2005, what is the difference between the General Parity Index (GPI) of Kazakhstan and General Parity Index (GPI) of St. Lucia?
Give a very brief answer. 0.05. In the year 2006, what is the difference between the General Parity Index (GPI) in Iceland and General Parity Index (GPI) in Jordan?
Offer a very short reply. -0.03. In the year 2006, what is the difference between the General Parity Index (GPI) of Iceland and General Parity Index (GPI) of Kazakhstan?
Offer a very short reply. -0.01. In the year 2006, what is the difference between the General Parity Index (GPI) of Iceland and General Parity Index (GPI) of St. Lucia?
Provide a short and direct response. 0.07. In the year 2006, what is the difference between the General Parity Index (GPI) of Jordan and General Parity Index (GPI) of Kazakhstan?
Your answer should be compact. 0.02. In the year 2006, what is the difference between the General Parity Index (GPI) of Jordan and General Parity Index (GPI) of St. Lucia?
Provide a short and direct response. 0.1. In the year 2006, what is the difference between the General Parity Index (GPI) of Kazakhstan and General Parity Index (GPI) of St. Lucia?
Offer a terse response. 0.08. What is the ratio of the General Parity Index (GPI) in Iceland in 1993 to that in 1999?
Make the answer very short. 1.02. What is the ratio of the General Parity Index (GPI) of Jordan in 1993 to that in 1999?
Your answer should be very brief. 1. What is the ratio of the General Parity Index (GPI) of Kazakhstan in 1993 to that in 1999?
Your answer should be very brief. 1.05. What is the ratio of the General Parity Index (GPI) in St. Lucia in 1993 to that in 1999?
Make the answer very short. 0.98. What is the ratio of the General Parity Index (GPI) in Iceland in 1993 to that in 2000?
Your answer should be very brief. 1.01. What is the ratio of the General Parity Index (GPI) of Kazakhstan in 1993 to that in 2000?
Make the answer very short. 1.05. What is the ratio of the General Parity Index (GPI) of St. Lucia in 1993 to that in 2000?
Offer a terse response. 0.96. What is the ratio of the General Parity Index (GPI) in Iceland in 1993 to that in 2002?
Offer a terse response. 1.01. What is the ratio of the General Parity Index (GPI) of Kazakhstan in 1993 to that in 2002?
Give a very brief answer. 1.06. What is the ratio of the General Parity Index (GPI) of St. Lucia in 1993 to that in 2002?
Make the answer very short. 0.96. What is the ratio of the General Parity Index (GPI) of Iceland in 1993 to that in 2003?
Offer a very short reply. 1.01. What is the ratio of the General Parity Index (GPI) in Kazakhstan in 1993 to that in 2003?
Offer a terse response. 1.05. What is the ratio of the General Parity Index (GPI) in St. Lucia in 1993 to that in 2003?
Keep it short and to the point. 0.98. What is the ratio of the General Parity Index (GPI) in Iceland in 1993 to that in 2004?
Provide a succinct answer. 1.02. What is the ratio of the General Parity Index (GPI) of Jordan in 1993 to that in 2004?
Keep it short and to the point. 1. What is the ratio of the General Parity Index (GPI) in Kazakhstan in 1993 to that in 2004?
Your answer should be compact. 1.06. What is the ratio of the General Parity Index (GPI) of St. Lucia in 1993 to that in 2004?
Your answer should be very brief. 0.98. What is the ratio of the General Parity Index (GPI) of Iceland in 1993 to that in 2005?
Provide a short and direct response. 1.02. What is the ratio of the General Parity Index (GPI) in Jordan in 1993 to that in 2005?
Provide a succinct answer. 1.01. What is the ratio of the General Parity Index (GPI) in Kazakhstan in 1993 to that in 2005?
Give a very brief answer. 1.06. What is the ratio of the General Parity Index (GPI) in St. Lucia in 1993 to that in 2005?
Your response must be concise. 0.97. What is the ratio of the General Parity Index (GPI) in Iceland in 1993 to that in 2006?
Make the answer very short. 1.01. What is the ratio of the General Parity Index (GPI) in Jordan in 1993 to that in 2006?
Your answer should be compact. 0.99. What is the ratio of the General Parity Index (GPI) of Kazakhstan in 1993 to that in 2006?
Your answer should be compact. 1.06. What is the ratio of the General Parity Index (GPI) of St. Lucia in 1993 to that in 2006?
Your answer should be very brief. 1.01. What is the ratio of the General Parity Index (GPI) of Iceland in 1999 to that in 2000?
Your response must be concise. 1. What is the ratio of the General Parity Index (GPI) of Jordan in 1999 to that in 2000?
Your answer should be very brief. 1. What is the ratio of the General Parity Index (GPI) of St. Lucia in 1999 to that in 2000?
Provide a short and direct response. 0.98. What is the ratio of the General Parity Index (GPI) of Iceland in 1999 to that in 2002?
Provide a succinct answer. 0.99. What is the ratio of the General Parity Index (GPI) of Kazakhstan in 1999 to that in 2002?
Your answer should be compact. 1.01. What is the ratio of the General Parity Index (GPI) of St. Lucia in 1999 to that in 2002?
Give a very brief answer. 0.98. What is the ratio of the General Parity Index (GPI) of Jordan in 1999 to that in 2003?
Ensure brevity in your answer.  1.01. What is the ratio of the General Parity Index (GPI) in Kazakhstan in 1999 to that in 2003?
Provide a succinct answer. 1. What is the ratio of the General Parity Index (GPI) of St. Lucia in 1999 to that in 2003?
Your response must be concise. 1. What is the ratio of the General Parity Index (GPI) in Jordan in 1999 to that in 2004?
Ensure brevity in your answer.  1.01. What is the ratio of the General Parity Index (GPI) in Kazakhstan in 1999 to that in 2004?
Ensure brevity in your answer.  1. What is the ratio of the General Parity Index (GPI) of St. Lucia in 1999 to that in 2004?
Offer a very short reply. 1. What is the ratio of the General Parity Index (GPI) of St. Lucia in 1999 to that in 2005?
Offer a terse response. 0.99. What is the ratio of the General Parity Index (GPI) in Iceland in 1999 to that in 2006?
Make the answer very short. 0.99. What is the ratio of the General Parity Index (GPI) in Jordan in 1999 to that in 2006?
Ensure brevity in your answer.  1. What is the ratio of the General Parity Index (GPI) of Kazakhstan in 1999 to that in 2006?
Offer a very short reply. 1.01. What is the ratio of the General Parity Index (GPI) in St. Lucia in 1999 to that in 2006?
Provide a short and direct response. 1.03. What is the ratio of the General Parity Index (GPI) in Jordan in 2000 to that in 2002?
Your answer should be very brief. 1.01. What is the ratio of the General Parity Index (GPI) of Kazakhstan in 2000 to that in 2002?
Give a very brief answer. 1.01. What is the ratio of the General Parity Index (GPI) of St. Lucia in 2000 to that in 2002?
Keep it short and to the point. 1. What is the ratio of the General Parity Index (GPI) in Kazakhstan in 2000 to that in 2003?
Offer a very short reply. 1.01. What is the ratio of the General Parity Index (GPI) in St. Lucia in 2000 to that in 2003?
Your answer should be compact. 1.02. What is the ratio of the General Parity Index (GPI) in Iceland in 2000 to that in 2004?
Ensure brevity in your answer.  1. What is the ratio of the General Parity Index (GPI) in Jordan in 2000 to that in 2004?
Provide a succinct answer. 1.01. What is the ratio of the General Parity Index (GPI) of Kazakhstan in 2000 to that in 2004?
Make the answer very short. 1.01. What is the ratio of the General Parity Index (GPI) of St. Lucia in 2000 to that in 2004?
Offer a terse response. 1.02. What is the ratio of the General Parity Index (GPI) in Jordan in 2000 to that in 2005?
Your response must be concise. 1.01. What is the ratio of the General Parity Index (GPI) of Kazakhstan in 2000 to that in 2005?
Your response must be concise. 1.01. What is the ratio of the General Parity Index (GPI) of St. Lucia in 2000 to that in 2005?
Give a very brief answer. 1.01. What is the ratio of the General Parity Index (GPI) of Kazakhstan in 2000 to that in 2006?
Your response must be concise. 1.01. What is the ratio of the General Parity Index (GPI) of St. Lucia in 2000 to that in 2006?
Provide a succinct answer. 1.05. What is the ratio of the General Parity Index (GPI) of Iceland in 2002 to that in 2003?
Your response must be concise. 1.01. What is the ratio of the General Parity Index (GPI) in Kazakhstan in 2002 to that in 2003?
Provide a short and direct response. 1. What is the ratio of the General Parity Index (GPI) of St. Lucia in 2002 to that in 2003?
Make the answer very short. 1.02. What is the ratio of the General Parity Index (GPI) in Iceland in 2002 to that in 2004?
Provide a short and direct response. 1.01. What is the ratio of the General Parity Index (GPI) in Jordan in 2002 to that in 2004?
Give a very brief answer. 1. What is the ratio of the General Parity Index (GPI) in Kazakhstan in 2002 to that in 2004?
Make the answer very short. 1. What is the ratio of the General Parity Index (GPI) in St. Lucia in 2002 to that in 2004?
Provide a short and direct response. 1.02. What is the ratio of the General Parity Index (GPI) in Iceland in 2002 to that in 2005?
Give a very brief answer. 1.01. What is the ratio of the General Parity Index (GPI) in Kazakhstan in 2002 to that in 2005?
Keep it short and to the point. 1. What is the ratio of the General Parity Index (GPI) of St. Lucia in 2002 to that in 2005?
Give a very brief answer. 1.01. What is the ratio of the General Parity Index (GPI) in Iceland in 2002 to that in 2006?
Make the answer very short. 1. What is the ratio of the General Parity Index (GPI) in St. Lucia in 2002 to that in 2006?
Your response must be concise. 1.05. What is the ratio of the General Parity Index (GPI) in Jordan in 2003 to that in 2004?
Offer a terse response. 1. What is the ratio of the General Parity Index (GPI) of Iceland in 2003 to that in 2005?
Your response must be concise. 1.01. What is the ratio of the General Parity Index (GPI) of Jordan in 2003 to that in 2006?
Offer a very short reply. 0.99. What is the ratio of the General Parity Index (GPI) in St. Lucia in 2003 to that in 2006?
Give a very brief answer. 1.03. What is the ratio of the General Parity Index (GPI) in Iceland in 2004 to that in 2005?
Your answer should be compact. 1. What is the ratio of the General Parity Index (GPI) of Kazakhstan in 2004 to that in 2005?
Make the answer very short. 1. What is the ratio of the General Parity Index (GPI) in Iceland in 2004 to that in 2006?
Provide a short and direct response. 0.99. What is the ratio of the General Parity Index (GPI) in Jordan in 2004 to that in 2006?
Provide a succinct answer. 0.99. What is the ratio of the General Parity Index (GPI) of Kazakhstan in 2004 to that in 2006?
Make the answer very short. 1. What is the ratio of the General Parity Index (GPI) in St. Lucia in 2004 to that in 2006?
Keep it short and to the point. 1.03. What is the ratio of the General Parity Index (GPI) in Iceland in 2005 to that in 2006?
Give a very brief answer. 0.99. What is the ratio of the General Parity Index (GPI) of Jordan in 2005 to that in 2006?
Keep it short and to the point. 0.99. What is the ratio of the General Parity Index (GPI) of St. Lucia in 2005 to that in 2006?
Offer a very short reply. 1.04. What is the difference between the highest and the second highest General Parity Index (GPI) of Iceland?
Ensure brevity in your answer.  0.01. What is the difference between the highest and the second highest General Parity Index (GPI) in Jordan?
Offer a terse response. 0. What is the difference between the highest and the second highest General Parity Index (GPI) in Kazakhstan?
Your answer should be compact. 0.05. What is the difference between the highest and the second highest General Parity Index (GPI) in St. Lucia?
Give a very brief answer. 0. What is the difference between the highest and the lowest General Parity Index (GPI) of Iceland?
Provide a succinct answer. 0.02. What is the difference between the highest and the lowest General Parity Index (GPI) in Jordan?
Your answer should be compact. 0.01. What is the difference between the highest and the lowest General Parity Index (GPI) in Kazakhstan?
Ensure brevity in your answer.  0.06. What is the difference between the highest and the lowest General Parity Index (GPI) of St. Lucia?
Keep it short and to the point. 0.05. 